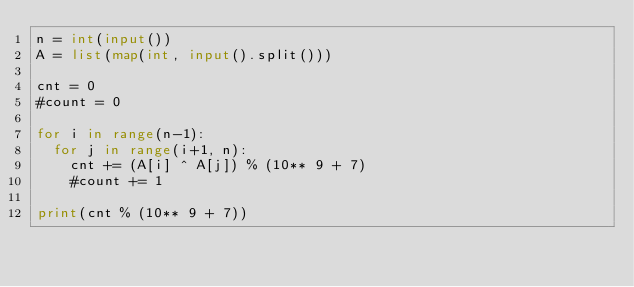Convert code to text. <code><loc_0><loc_0><loc_500><loc_500><_Python_>n = int(input())
A = list(map(int, input().split()))

cnt = 0
#count = 0

for i in range(n-1):
  for j in range(i+1, n):
    cnt += (A[i] ^ A[j]) % (10** 9 + 7)
    #count += 1
    
print(cnt % (10** 9 + 7))</code> 